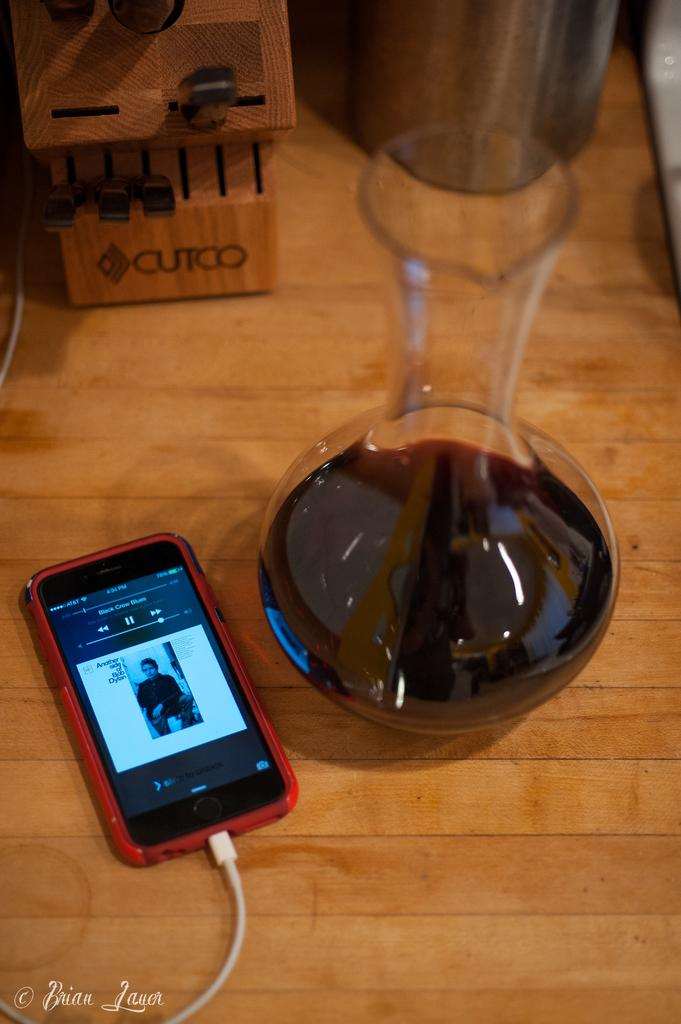<image>
Relay a brief, clear account of the picture shown. A smartphone is plugged in and playing Black Crow Blues. 